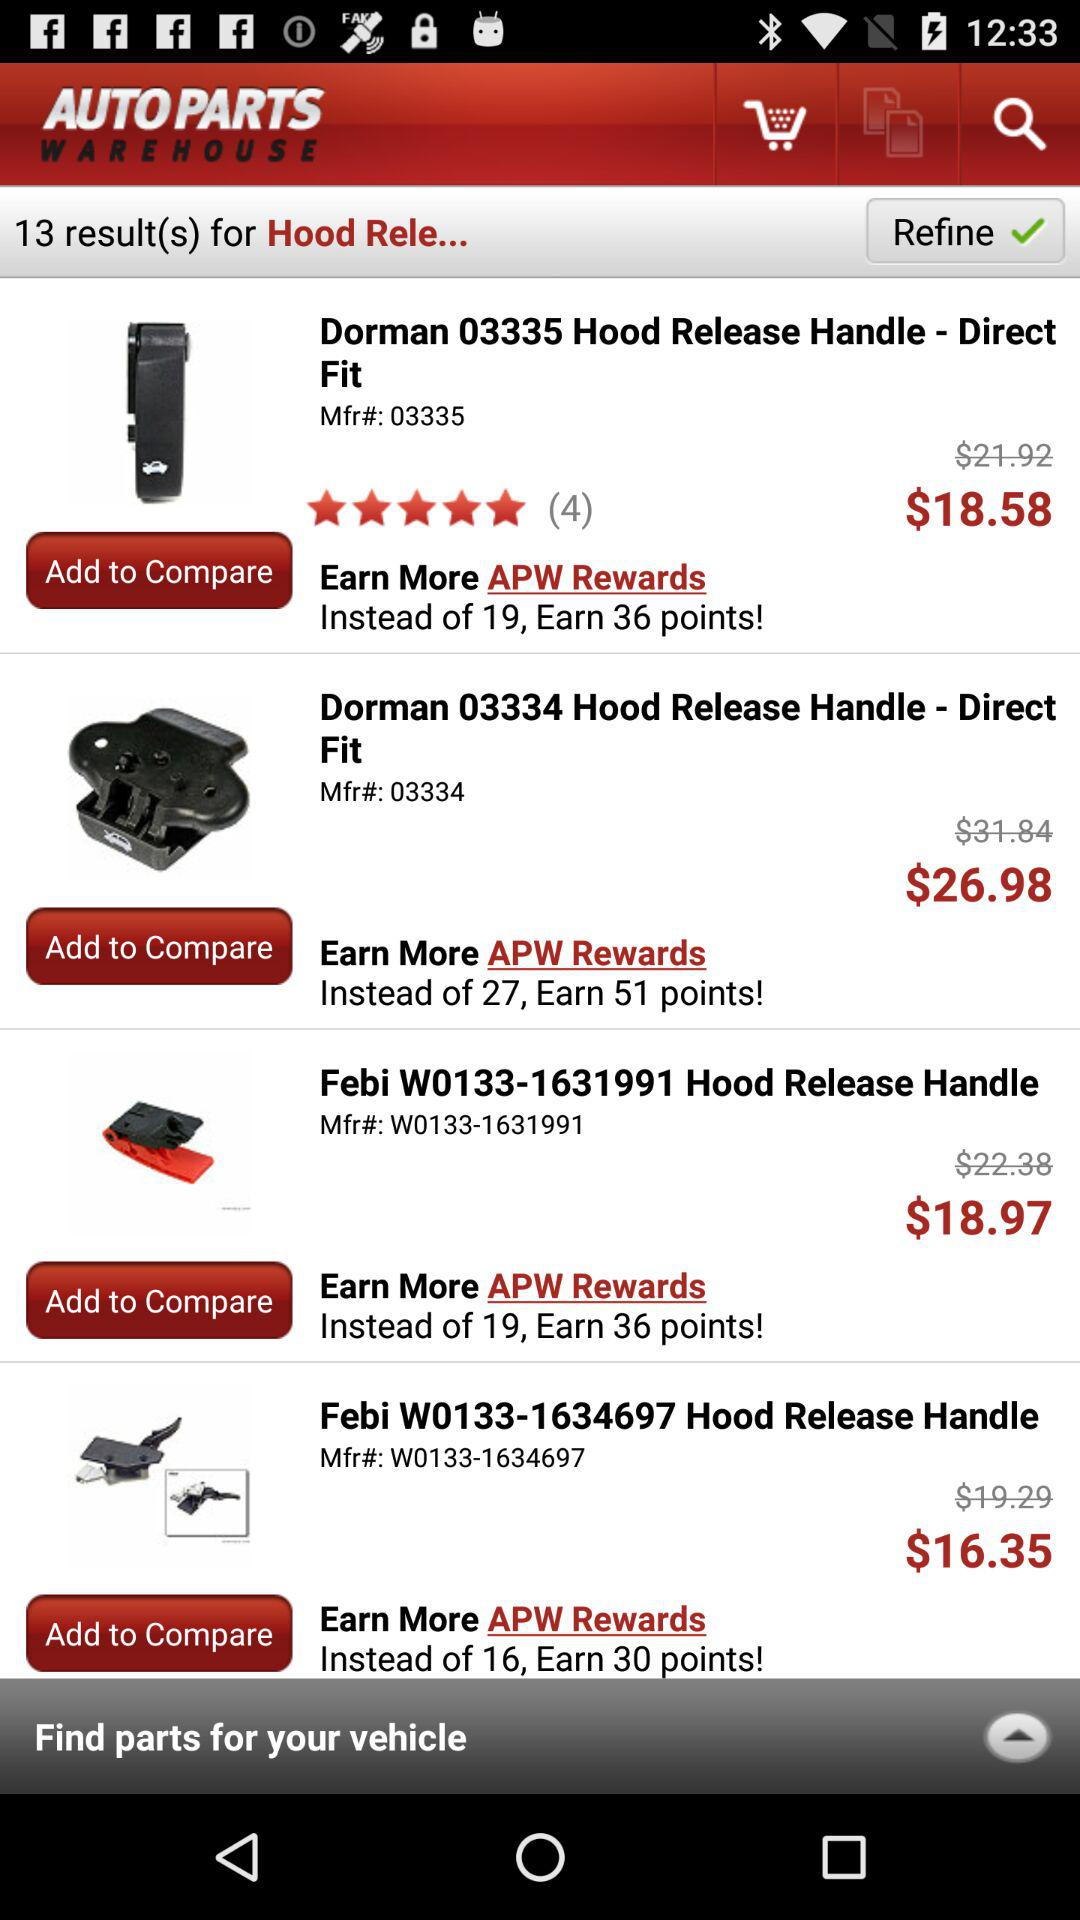How many results have a price of less than $20?
Answer the question using a single word or phrase. 3 